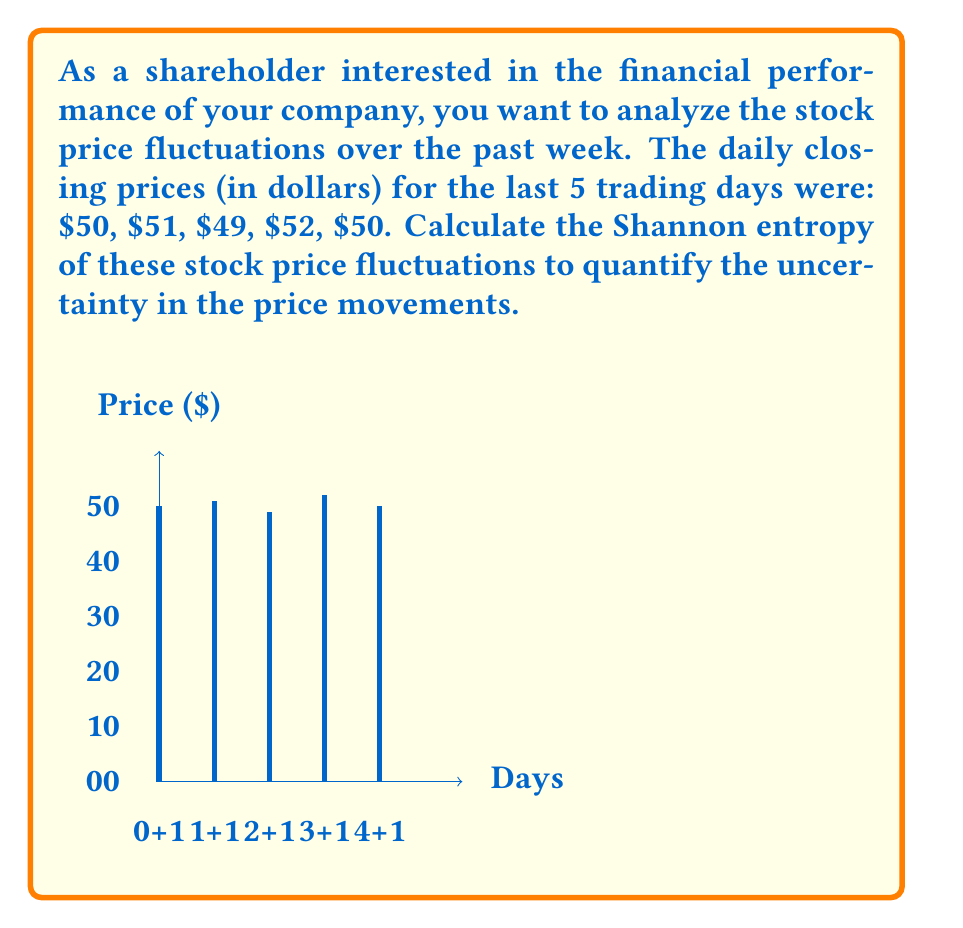Teach me how to tackle this problem. To calculate the Shannon entropy of the stock price fluctuations, we'll follow these steps:

1) First, we need to determine the probability distribution of the prices. We have 5 data points:
   $50 (twice), $51, $49, $52

2) Calculate the probability of each unique price:
   P($50) = 2/5 = 0.4
   P($51) = 1/5 = 0.2
   P($49) = 1/5 = 0.2
   P($52) = 1/5 = 0.2

3) The Shannon entropy formula is:
   $$H = -\sum_{i=1}^{n} p_i \log_2(p_i)$$
   where $p_i$ is the probability of each event.

4) Let's calculate each term:
   For $50: -0.4 \log_2(0.4) = 0.528771$
   For $51: -0.2 \log_2(0.2) = 0.464386$
   For $49: -0.2 \log_2(0.2) = 0.464386$
   For $52: -0.2 \log_2(0.2) = 0.464386$

5) Sum all these terms:
   $$H = 0.528771 + 0.464386 + 0.464386 + 0.464386 = 1.921929$$

6) Therefore, the Shannon entropy of the stock price fluctuations is approximately 1.92 bits.

This value quantifies the uncertainty in the stock price movements. A higher entropy indicates more unpredictable fluctuations, while a lower entropy suggests more predictable patterns.
Answer: 1.92 bits 